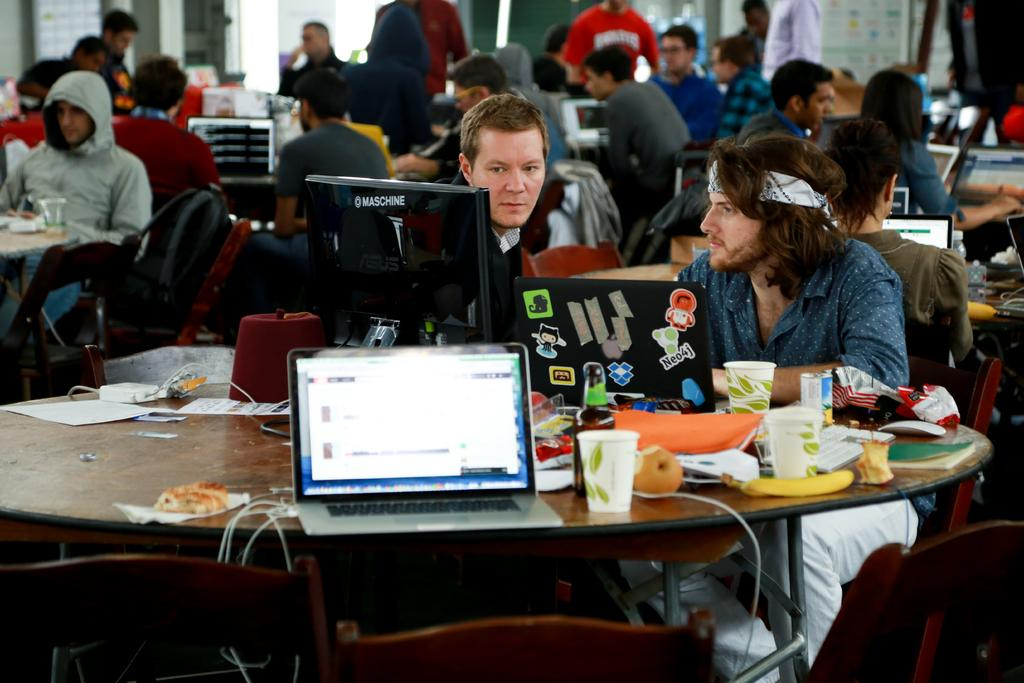What are the persons in the image doing? The persons in the image are sitting on chairs. What objects can be seen on the tables in the image? Laptops, glasses, and papers are present on the tables in the image. What is the background of the image? There is a wall in the background of the image. How many sticks can be seen in the image? There are no sticks present in the image. What type of error can be seen on the laptops in the image? There is no indication of any errors on the laptops in the image. 